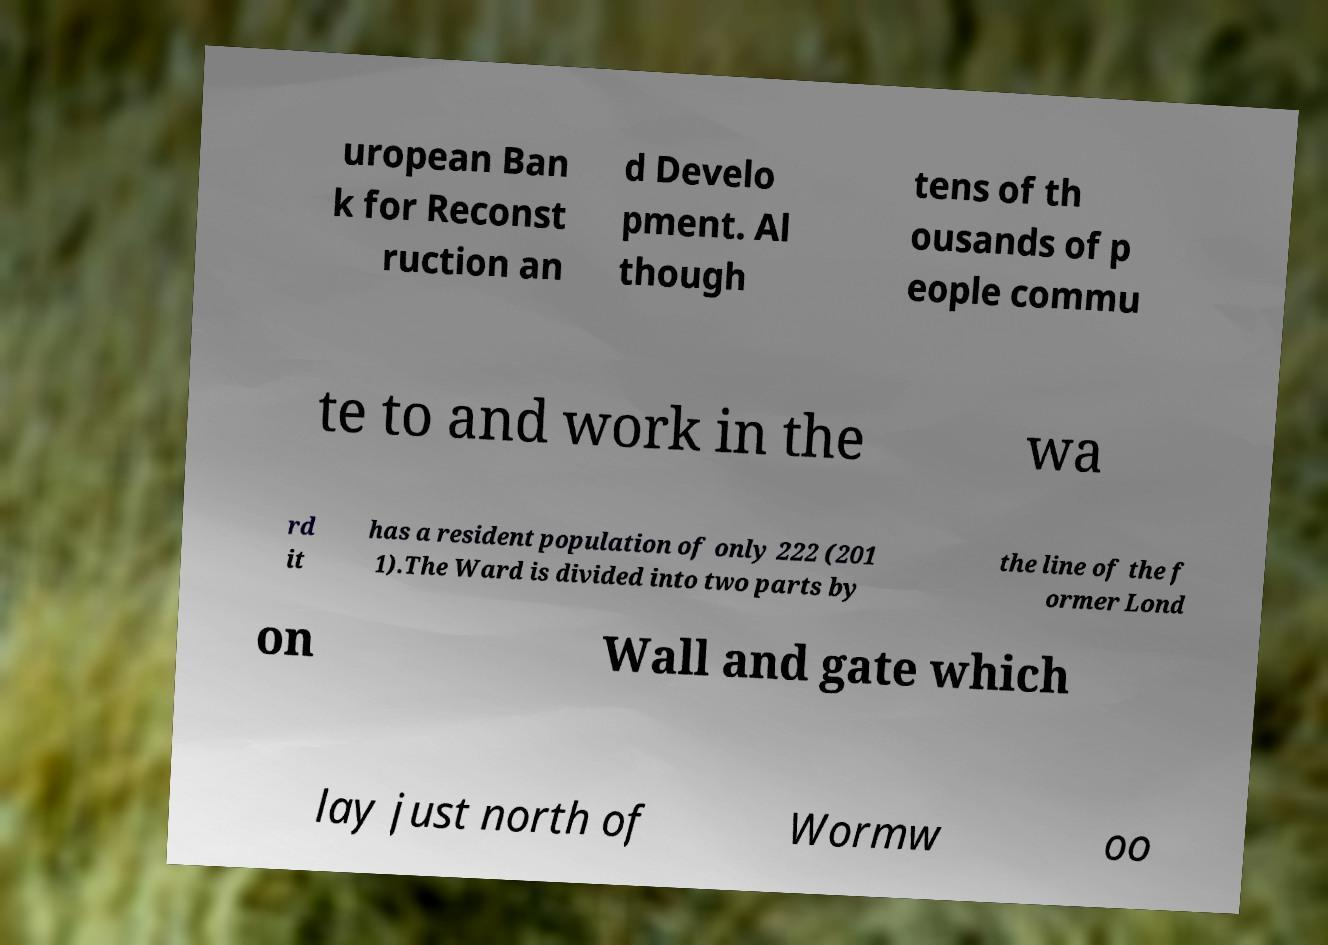What messages or text are displayed in this image? I need them in a readable, typed format. uropean Ban k for Reconst ruction an d Develo pment. Al though tens of th ousands of p eople commu te to and work in the wa rd it has a resident population of only 222 (201 1).The Ward is divided into two parts by the line of the f ormer Lond on Wall and gate which lay just north of Wormw oo 